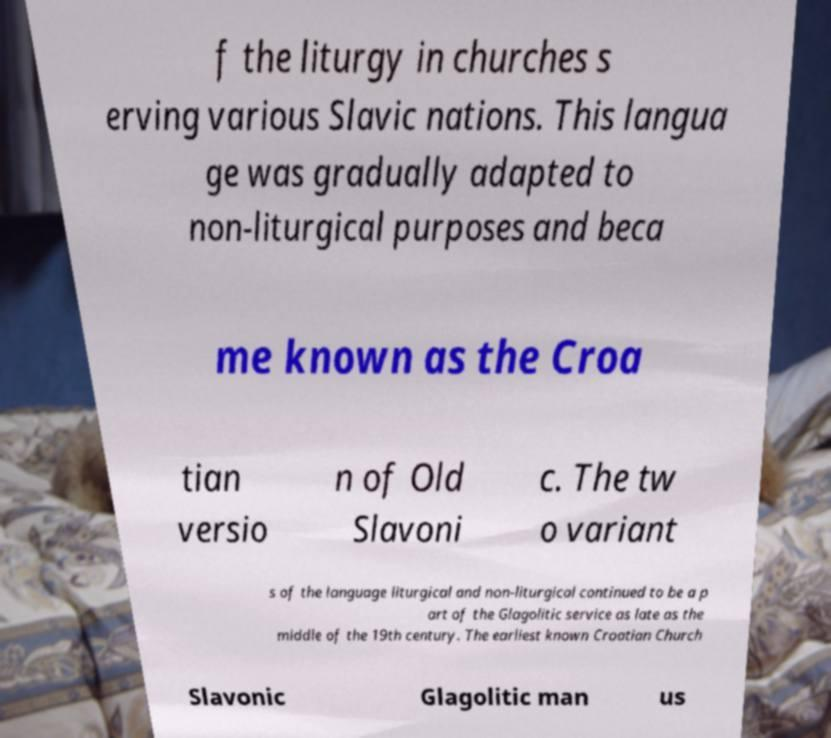There's text embedded in this image that I need extracted. Can you transcribe it verbatim? f the liturgy in churches s erving various Slavic nations. This langua ge was gradually adapted to non-liturgical purposes and beca me known as the Croa tian versio n of Old Slavoni c. The tw o variant s of the language liturgical and non-liturgical continued to be a p art of the Glagolitic service as late as the middle of the 19th century. The earliest known Croatian Church Slavonic Glagolitic man us 